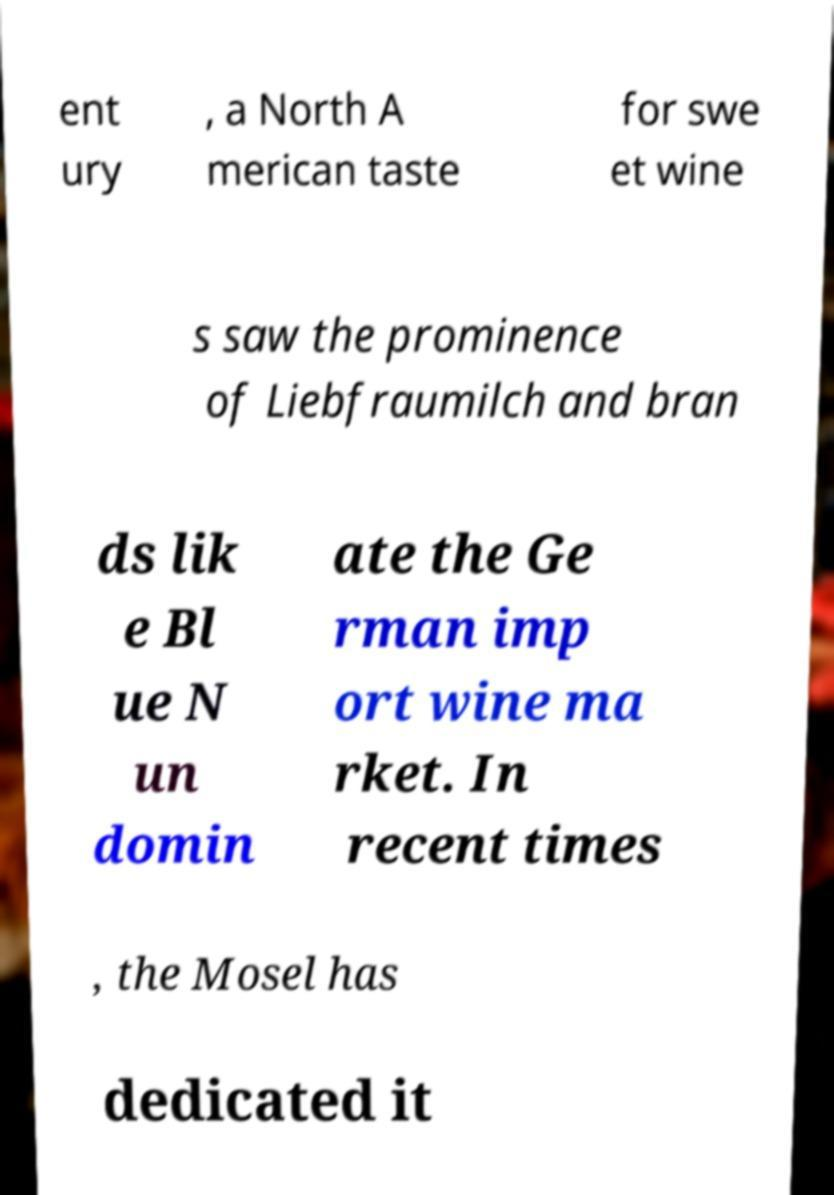Could you extract and type out the text from this image? ent ury , a North A merican taste for swe et wine s saw the prominence of Liebfraumilch and bran ds lik e Bl ue N un domin ate the Ge rman imp ort wine ma rket. In recent times , the Mosel has dedicated it 